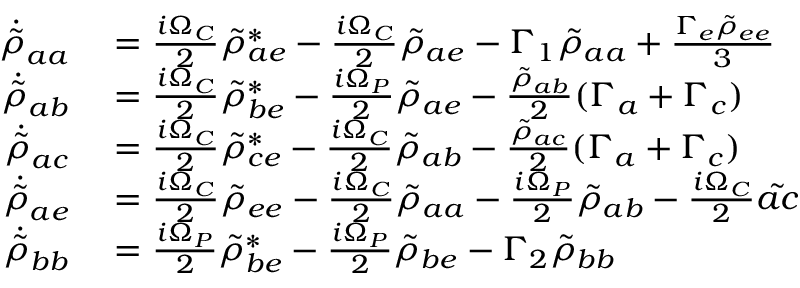<formula> <loc_0><loc_0><loc_500><loc_500>\begin{array} { r l } { \ D o t { \tilde { \rho } } _ { a a } } & = \frac { i \Omega _ { C } } { 2 } \tilde { \rho } _ { a e } ^ { * } - \frac { i \Omega _ { C } } { 2 } \tilde { \rho } _ { a e } - \Gamma _ { 1 } \tilde { \rho } _ { a a } + \frac { \Gamma _ { e } \tilde { \rho } _ { e e } } { 3 } } \\ { \ D o t { \tilde { \rho } } _ { a b } } & = \frac { i \Omega _ { C } } { 2 } \tilde { \rho } _ { b e } ^ { * } - \frac { i \Omega _ { P } } { 2 } \tilde { \rho } _ { a e } - \frac { \tilde { \rho } _ { a b } } { 2 } ( \Gamma _ { a } + \Gamma _ { c } ) } \\ { \ D o t { \tilde { \rho } } _ { a c } } & = \frac { i \Omega _ { C } } { 2 } \tilde { \rho } _ { c e } ^ { * } - \frac { i \Omega _ { C } } { 2 } \tilde { \rho } _ { a b } - \frac { \tilde { \rho } _ { a c } } { 2 } ( \Gamma _ { a } + \Gamma _ { c } ) } \\ { \ D o t { \tilde { \rho } } _ { a e } } & = \frac { i \Omega _ { C } } { 2 } \tilde { \rho } _ { e e } - \frac { i \Omega _ { C } } { 2 } \tilde { \rho } _ { a a } - \frac { i \Omega _ { P } } { 2 } \tilde { \rho } _ { a b } - \frac { i \Omega _ { C } } { 2 } \tilde { a c } } \\ { \ D o t { \tilde { \rho } } _ { b b } } & = \frac { i \Omega _ { P } } { 2 } \tilde { \rho } _ { b e } ^ { * } - \frac { i \Omega _ { P } } { 2 } \tilde { \rho } _ { b e } - \Gamma _ { 2 } \tilde { \rho } _ { b b } } \end{array}</formula> 